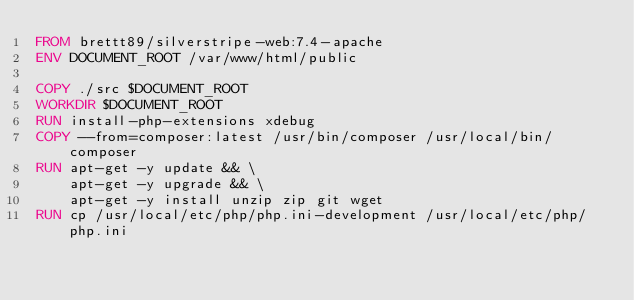Convert code to text. <code><loc_0><loc_0><loc_500><loc_500><_Dockerfile_>FROM brettt89/silverstripe-web:7.4-apache
ENV DOCUMENT_ROOT /var/www/html/public

COPY ./src $DOCUMENT_ROOT
WORKDIR $DOCUMENT_ROOT
RUN install-php-extensions xdebug
COPY --from=composer:latest /usr/bin/composer /usr/local/bin/composer
RUN apt-get -y update && \
    apt-get -y upgrade && \
    apt-get -y install unzip zip git wget
RUN cp /usr/local/etc/php/php.ini-development /usr/local/etc/php/php.ini</code> 